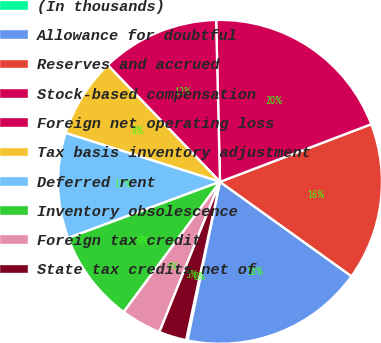<chart> <loc_0><loc_0><loc_500><loc_500><pie_chart><fcel>(In thousands)<fcel>Allowance for doubtful<fcel>Reserves and accrued<fcel>Stock-based compensation<fcel>Foreign net operating loss<fcel>Tax basis inventory adjustment<fcel>Deferred rent<fcel>Inventory obsolescence<fcel>Foreign tax credit<fcel>State tax credits net of<nl><fcel>0.15%<fcel>18.3%<fcel>15.7%<fcel>19.59%<fcel>11.81%<fcel>7.93%<fcel>10.52%<fcel>9.22%<fcel>4.04%<fcel>2.74%<nl></chart> 